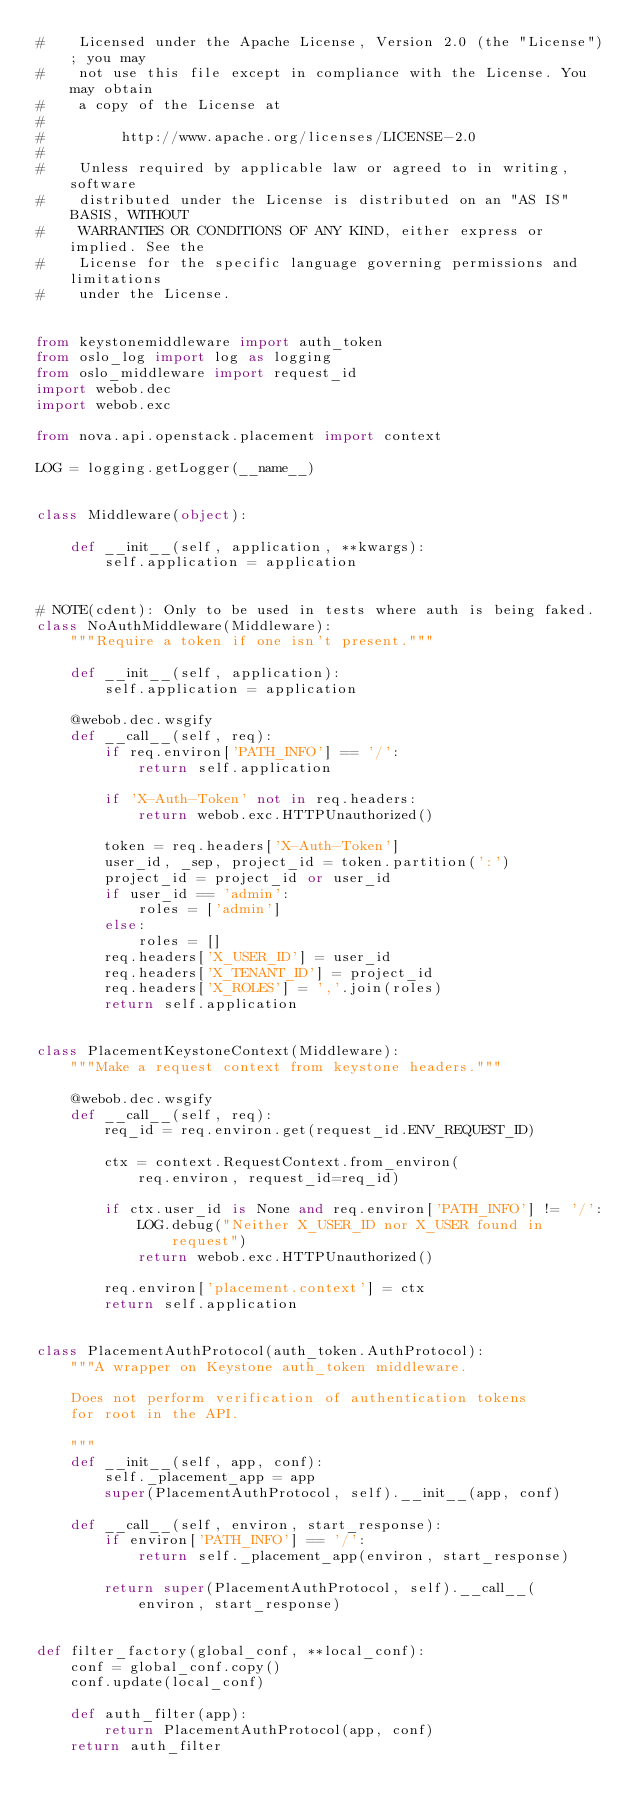Convert code to text. <code><loc_0><loc_0><loc_500><loc_500><_Python_>#    Licensed under the Apache License, Version 2.0 (the "License"); you may
#    not use this file except in compliance with the License. You may obtain
#    a copy of the License at
#
#         http://www.apache.org/licenses/LICENSE-2.0
#
#    Unless required by applicable law or agreed to in writing, software
#    distributed under the License is distributed on an "AS IS" BASIS, WITHOUT
#    WARRANTIES OR CONDITIONS OF ANY KIND, either express or implied. See the
#    License for the specific language governing permissions and limitations
#    under the License.


from keystonemiddleware import auth_token
from oslo_log import log as logging
from oslo_middleware import request_id
import webob.dec
import webob.exc

from nova.api.openstack.placement import context

LOG = logging.getLogger(__name__)


class Middleware(object):

    def __init__(self, application, **kwargs):
        self.application = application


# NOTE(cdent): Only to be used in tests where auth is being faked.
class NoAuthMiddleware(Middleware):
    """Require a token if one isn't present."""

    def __init__(self, application):
        self.application = application

    @webob.dec.wsgify
    def __call__(self, req):
        if req.environ['PATH_INFO'] == '/':
            return self.application

        if 'X-Auth-Token' not in req.headers:
            return webob.exc.HTTPUnauthorized()

        token = req.headers['X-Auth-Token']
        user_id, _sep, project_id = token.partition(':')
        project_id = project_id or user_id
        if user_id == 'admin':
            roles = ['admin']
        else:
            roles = []
        req.headers['X_USER_ID'] = user_id
        req.headers['X_TENANT_ID'] = project_id
        req.headers['X_ROLES'] = ','.join(roles)
        return self.application


class PlacementKeystoneContext(Middleware):
    """Make a request context from keystone headers."""

    @webob.dec.wsgify
    def __call__(self, req):
        req_id = req.environ.get(request_id.ENV_REQUEST_ID)

        ctx = context.RequestContext.from_environ(
            req.environ, request_id=req_id)

        if ctx.user_id is None and req.environ['PATH_INFO'] != '/':
            LOG.debug("Neither X_USER_ID nor X_USER found in request")
            return webob.exc.HTTPUnauthorized()

        req.environ['placement.context'] = ctx
        return self.application


class PlacementAuthProtocol(auth_token.AuthProtocol):
    """A wrapper on Keystone auth_token middleware.

    Does not perform verification of authentication tokens
    for root in the API.

    """
    def __init__(self, app, conf):
        self._placement_app = app
        super(PlacementAuthProtocol, self).__init__(app, conf)

    def __call__(self, environ, start_response):
        if environ['PATH_INFO'] == '/':
            return self._placement_app(environ, start_response)

        return super(PlacementAuthProtocol, self).__call__(
            environ, start_response)


def filter_factory(global_conf, **local_conf):
    conf = global_conf.copy()
    conf.update(local_conf)

    def auth_filter(app):
        return PlacementAuthProtocol(app, conf)
    return auth_filter
</code> 